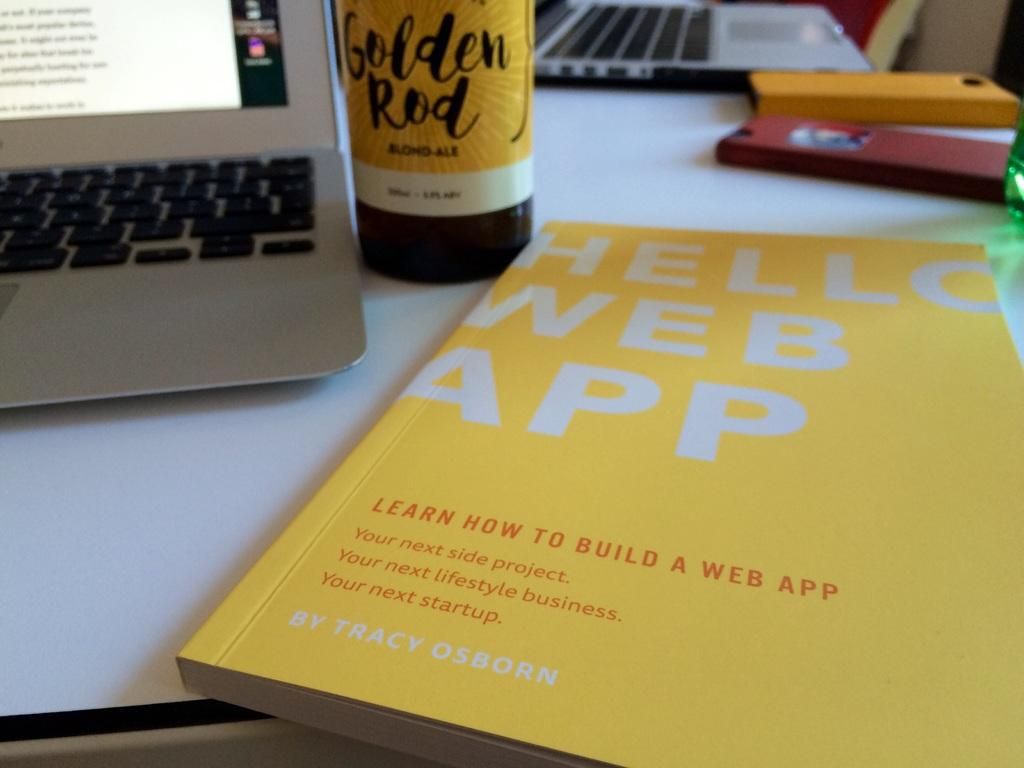<image>
Write a terse but informative summary of the picture. a book that has the words web app on it 